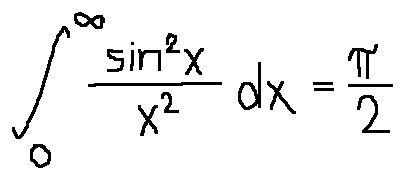<formula> <loc_0><loc_0><loc_500><loc_500>\int \lim i t s _ { 0 } ^ { \infty } \frac { \sin ^ { 2 } x } { x ^ { 2 } } d x = \frac { \pi } { 2 }</formula> 